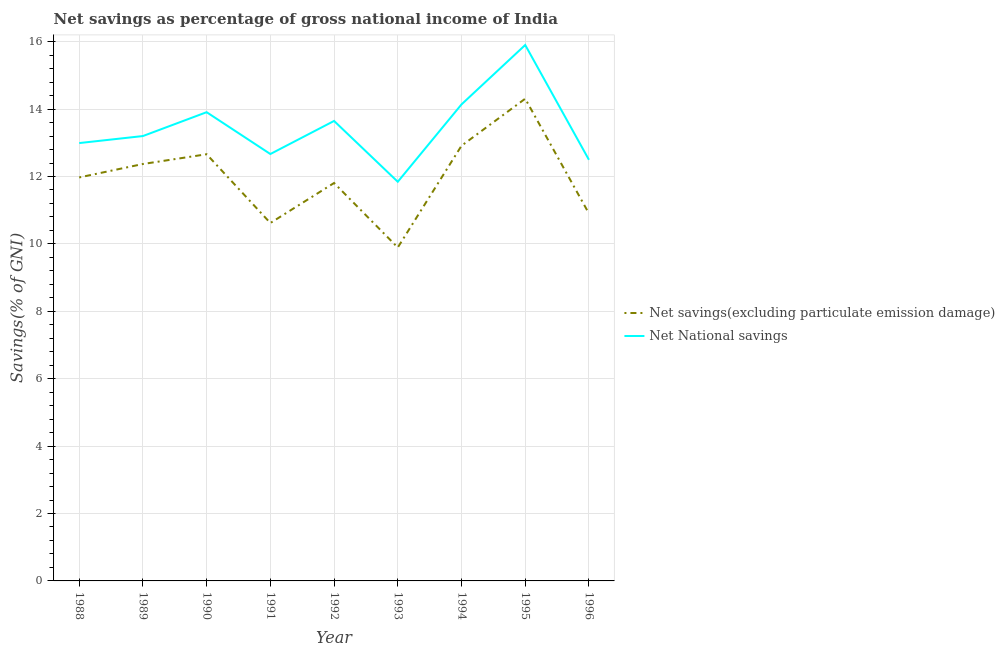How many different coloured lines are there?
Give a very brief answer. 2. Does the line corresponding to net national savings intersect with the line corresponding to net savings(excluding particulate emission damage)?
Your answer should be compact. No. Is the number of lines equal to the number of legend labels?
Make the answer very short. Yes. What is the net savings(excluding particulate emission damage) in 1994?
Your response must be concise. 12.91. Across all years, what is the maximum net savings(excluding particulate emission damage)?
Your answer should be compact. 14.31. Across all years, what is the minimum net savings(excluding particulate emission damage)?
Offer a terse response. 9.89. In which year was the net savings(excluding particulate emission damage) minimum?
Your answer should be compact. 1993. What is the total net national savings in the graph?
Offer a very short reply. 120.79. What is the difference between the net savings(excluding particulate emission damage) in 1993 and that in 1996?
Your answer should be very brief. -1.01. What is the difference between the net national savings in 1995 and the net savings(excluding particulate emission damage) in 1992?
Offer a terse response. 4.09. What is the average net savings(excluding particulate emission damage) per year?
Provide a short and direct response. 11.94. In the year 1989, what is the difference between the net national savings and net savings(excluding particulate emission damage)?
Your answer should be very brief. 0.83. In how many years, is the net savings(excluding particulate emission damage) greater than 14 %?
Offer a very short reply. 1. What is the ratio of the net national savings in 1990 to that in 1996?
Offer a terse response. 1.11. What is the difference between the highest and the second highest net national savings?
Make the answer very short. 1.76. What is the difference between the highest and the lowest net national savings?
Give a very brief answer. 4.06. Is the sum of the net national savings in 1990 and 1991 greater than the maximum net savings(excluding particulate emission damage) across all years?
Offer a very short reply. Yes. Does the net savings(excluding particulate emission damage) monotonically increase over the years?
Ensure brevity in your answer.  No. Is the net savings(excluding particulate emission damage) strictly less than the net national savings over the years?
Make the answer very short. Yes. How many years are there in the graph?
Give a very brief answer. 9. What is the difference between two consecutive major ticks on the Y-axis?
Provide a short and direct response. 2. Are the values on the major ticks of Y-axis written in scientific E-notation?
Make the answer very short. No. Does the graph contain any zero values?
Keep it short and to the point. No. How are the legend labels stacked?
Keep it short and to the point. Vertical. What is the title of the graph?
Your answer should be compact. Net savings as percentage of gross national income of India. Does "Broad money growth" appear as one of the legend labels in the graph?
Keep it short and to the point. No. What is the label or title of the Y-axis?
Make the answer very short. Savings(% of GNI). What is the Savings(% of GNI) of Net savings(excluding particulate emission damage) in 1988?
Provide a succinct answer. 11.97. What is the Savings(% of GNI) of Net National savings in 1988?
Offer a terse response. 12.99. What is the Savings(% of GNI) of Net savings(excluding particulate emission damage) in 1989?
Provide a succinct answer. 12.37. What is the Savings(% of GNI) of Net National savings in 1989?
Provide a succinct answer. 13.2. What is the Savings(% of GNI) in Net savings(excluding particulate emission damage) in 1990?
Give a very brief answer. 12.66. What is the Savings(% of GNI) of Net National savings in 1990?
Your answer should be very brief. 13.91. What is the Savings(% of GNI) of Net savings(excluding particulate emission damage) in 1991?
Offer a terse response. 10.62. What is the Savings(% of GNI) in Net National savings in 1991?
Your answer should be very brief. 12.67. What is the Savings(% of GNI) in Net savings(excluding particulate emission damage) in 1992?
Provide a short and direct response. 11.81. What is the Savings(% of GNI) in Net National savings in 1992?
Make the answer very short. 13.65. What is the Savings(% of GNI) of Net savings(excluding particulate emission damage) in 1993?
Your answer should be very brief. 9.89. What is the Savings(% of GNI) of Net National savings in 1993?
Your response must be concise. 11.84. What is the Savings(% of GNI) of Net savings(excluding particulate emission damage) in 1994?
Your answer should be compact. 12.91. What is the Savings(% of GNI) of Net National savings in 1994?
Provide a succinct answer. 14.14. What is the Savings(% of GNI) of Net savings(excluding particulate emission damage) in 1995?
Offer a terse response. 14.31. What is the Savings(% of GNI) of Net National savings in 1995?
Provide a succinct answer. 15.9. What is the Savings(% of GNI) in Net savings(excluding particulate emission damage) in 1996?
Ensure brevity in your answer.  10.9. What is the Savings(% of GNI) in Net National savings in 1996?
Offer a very short reply. 12.5. Across all years, what is the maximum Savings(% of GNI) in Net savings(excluding particulate emission damage)?
Give a very brief answer. 14.31. Across all years, what is the maximum Savings(% of GNI) of Net National savings?
Provide a short and direct response. 15.9. Across all years, what is the minimum Savings(% of GNI) of Net savings(excluding particulate emission damage)?
Provide a succinct answer. 9.89. Across all years, what is the minimum Savings(% of GNI) in Net National savings?
Your response must be concise. 11.84. What is the total Savings(% of GNI) of Net savings(excluding particulate emission damage) in the graph?
Your response must be concise. 107.44. What is the total Savings(% of GNI) in Net National savings in the graph?
Ensure brevity in your answer.  120.79. What is the difference between the Savings(% of GNI) in Net savings(excluding particulate emission damage) in 1988 and that in 1989?
Keep it short and to the point. -0.4. What is the difference between the Savings(% of GNI) of Net National savings in 1988 and that in 1989?
Provide a short and direct response. -0.21. What is the difference between the Savings(% of GNI) in Net savings(excluding particulate emission damage) in 1988 and that in 1990?
Provide a succinct answer. -0.69. What is the difference between the Savings(% of GNI) in Net National savings in 1988 and that in 1990?
Offer a very short reply. -0.92. What is the difference between the Savings(% of GNI) of Net savings(excluding particulate emission damage) in 1988 and that in 1991?
Ensure brevity in your answer.  1.35. What is the difference between the Savings(% of GNI) in Net National savings in 1988 and that in 1991?
Ensure brevity in your answer.  0.32. What is the difference between the Savings(% of GNI) in Net savings(excluding particulate emission damage) in 1988 and that in 1992?
Provide a short and direct response. 0.17. What is the difference between the Savings(% of GNI) in Net National savings in 1988 and that in 1992?
Your response must be concise. -0.66. What is the difference between the Savings(% of GNI) in Net savings(excluding particulate emission damage) in 1988 and that in 1993?
Your response must be concise. 2.08. What is the difference between the Savings(% of GNI) in Net National savings in 1988 and that in 1993?
Your answer should be very brief. 1.15. What is the difference between the Savings(% of GNI) in Net savings(excluding particulate emission damage) in 1988 and that in 1994?
Provide a succinct answer. -0.94. What is the difference between the Savings(% of GNI) in Net National savings in 1988 and that in 1994?
Offer a terse response. -1.15. What is the difference between the Savings(% of GNI) in Net savings(excluding particulate emission damage) in 1988 and that in 1995?
Offer a very short reply. -2.34. What is the difference between the Savings(% of GNI) of Net National savings in 1988 and that in 1995?
Your answer should be compact. -2.91. What is the difference between the Savings(% of GNI) in Net savings(excluding particulate emission damage) in 1988 and that in 1996?
Offer a very short reply. 1.07. What is the difference between the Savings(% of GNI) in Net National savings in 1988 and that in 1996?
Offer a very short reply. 0.5. What is the difference between the Savings(% of GNI) of Net savings(excluding particulate emission damage) in 1989 and that in 1990?
Ensure brevity in your answer.  -0.29. What is the difference between the Savings(% of GNI) of Net National savings in 1989 and that in 1990?
Offer a terse response. -0.71. What is the difference between the Savings(% of GNI) of Net savings(excluding particulate emission damage) in 1989 and that in 1991?
Your answer should be compact. 1.75. What is the difference between the Savings(% of GNI) in Net National savings in 1989 and that in 1991?
Your answer should be very brief. 0.53. What is the difference between the Savings(% of GNI) of Net savings(excluding particulate emission damage) in 1989 and that in 1992?
Offer a very short reply. 0.56. What is the difference between the Savings(% of GNI) in Net National savings in 1989 and that in 1992?
Offer a terse response. -0.45. What is the difference between the Savings(% of GNI) of Net savings(excluding particulate emission damage) in 1989 and that in 1993?
Your answer should be compact. 2.48. What is the difference between the Savings(% of GNI) in Net National savings in 1989 and that in 1993?
Your answer should be very brief. 1.36. What is the difference between the Savings(% of GNI) of Net savings(excluding particulate emission damage) in 1989 and that in 1994?
Ensure brevity in your answer.  -0.54. What is the difference between the Savings(% of GNI) in Net National savings in 1989 and that in 1994?
Make the answer very short. -0.94. What is the difference between the Savings(% of GNI) of Net savings(excluding particulate emission damage) in 1989 and that in 1995?
Your response must be concise. -1.94. What is the difference between the Savings(% of GNI) of Net National savings in 1989 and that in 1995?
Ensure brevity in your answer.  -2.7. What is the difference between the Savings(% of GNI) in Net savings(excluding particulate emission damage) in 1989 and that in 1996?
Your answer should be compact. 1.47. What is the difference between the Savings(% of GNI) in Net National savings in 1989 and that in 1996?
Provide a short and direct response. 0.7. What is the difference between the Savings(% of GNI) of Net savings(excluding particulate emission damage) in 1990 and that in 1991?
Ensure brevity in your answer.  2.04. What is the difference between the Savings(% of GNI) of Net National savings in 1990 and that in 1991?
Offer a terse response. 1.24. What is the difference between the Savings(% of GNI) of Net savings(excluding particulate emission damage) in 1990 and that in 1992?
Keep it short and to the point. 0.85. What is the difference between the Savings(% of GNI) in Net National savings in 1990 and that in 1992?
Your answer should be compact. 0.26. What is the difference between the Savings(% of GNI) in Net savings(excluding particulate emission damage) in 1990 and that in 1993?
Your answer should be very brief. 2.77. What is the difference between the Savings(% of GNI) in Net National savings in 1990 and that in 1993?
Make the answer very short. 2.06. What is the difference between the Savings(% of GNI) in Net savings(excluding particulate emission damage) in 1990 and that in 1994?
Give a very brief answer. -0.25. What is the difference between the Savings(% of GNI) in Net National savings in 1990 and that in 1994?
Ensure brevity in your answer.  -0.23. What is the difference between the Savings(% of GNI) in Net savings(excluding particulate emission damage) in 1990 and that in 1995?
Your answer should be compact. -1.65. What is the difference between the Savings(% of GNI) in Net National savings in 1990 and that in 1995?
Your response must be concise. -1.99. What is the difference between the Savings(% of GNI) in Net savings(excluding particulate emission damage) in 1990 and that in 1996?
Give a very brief answer. 1.76. What is the difference between the Savings(% of GNI) of Net National savings in 1990 and that in 1996?
Your answer should be very brief. 1.41. What is the difference between the Savings(% of GNI) of Net savings(excluding particulate emission damage) in 1991 and that in 1992?
Provide a short and direct response. -1.19. What is the difference between the Savings(% of GNI) of Net National savings in 1991 and that in 1992?
Give a very brief answer. -0.98. What is the difference between the Savings(% of GNI) in Net savings(excluding particulate emission damage) in 1991 and that in 1993?
Ensure brevity in your answer.  0.73. What is the difference between the Savings(% of GNI) of Net National savings in 1991 and that in 1993?
Make the answer very short. 0.82. What is the difference between the Savings(% of GNI) in Net savings(excluding particulate emission damage) in 1991 and that in 1994?
Your answer should be very brief. -2.29. What is the difference between the Savings(% of GNI) in Net National savings in 1991 and that in 1994?
Provide a short and direct response. -1.47. What is the difference between the Savings(% of GNI) of Net savings(excluding particulate emission damage) in 1991 and that in 1995?
Your answer should be very brief. -3.69. What is the difference between the Savings(% of GNI) in Net National savings in 1991 and that in 1995?
Your answer should be very brief. -3.23. What is the difference between the Savings(% of GNI) of Net savings(excluding particulate emission damage) in 1991 and that in 1996?
Your response must be concise. -0.28. What is the difference between the Savings(% of GNI) of Net National savings in 1991 and that in 1996?
Your response must be concise. 0.17. What is the difference between the Savings(% of GNI) of Net savings(excluding particulate emission damage) in 1992 and that in 1993?
Your response must be concise. 1.91. What is the difference between the Savings(% of GNI) of Net National savings in 1992 and that in 1993?
Offer a very short reply. 1.8. What is the difference between the Savings(% of GNI) of Net savings(excluding particulate emission damage) in 1992 and that in 1994?
Offer a terse response. -1.1. What is the difference between the Savings(% of GNI) in Net National savings in 1992 and that in 1994?
Keep it short and to the point. -0.49. What is the difference between the Savings(% of GNI) in Net savings(excluding particulate emission damage) in 1992 and that in 1995?
Your answer should be compact. -2.5. What is the difference between the Savings(% of GNI) in Net National savings in 1992 and that in 1995?
Your answer should be compact. -2.25. What is the difference between the Savings(% of GNI) in Net savings(excluding particulate emission damage) in 1992 and that in 1996?
Give a very brief answer. 0.91. What is the difference between the Savings(% of GNI) of Net National savings in 1992 and that in 1996?
Your response must be concise. 1.15. What is the difference between the Savings(% of GNI) in Net savings(excluding particulate emission damage) in 1993 and that in 1994?
Provide a succinct answer. -3.02. What is the difference between the Savings(% of GNI) of Net National savings in 1993 and that in 1994?
Provide a short and direct response. -2.3. What is the difference between the Savings(% of GNI) of Net savings(excluding particulate emission damage) in 1993 and that in 1995?
Give a very brief answer. -4.42. What is the difference between the Savings(% of GNI) of Net National savings in 1993 and that in 1995?
Give a very brief answer. -4.06. What is the difference between the Savings(% of GNI) of Net savings(excluding particulate emission damage) in 1993 and that in 1996?
Provide a succinct answer. -1.01. What is the difference between the Savings(% of GNI) in Net National savings in 1993 and that in 1996?
Provide a short and direct response. -0.65. What is the difference between the Savings(% of GNI) in Net savings(excluding particulate emission damage) in 1994 and that in 1995?
Give a very brief answer. -1.4. What is the difference between the Savings(% of GNI) of Net National savings in 1994 and that in 1995?
Your answer should be compact. -1.76. What is the difference between the Savings(% of GNI) of Net savings(excluding particulate emission damage) in 1994 and that in 1996?
Your answer should be compact. 2.01. What is the difference between the Savings(% of GNI) of Net National savings in 1994 and that in 1996?
Offer a very short reply. 1.64. What is the difference between the Savings(% of GNI) in Net savings(excluding particulate emission damage) in 1995 and that in 1996?
Your response must be concise. 3.41. What is the difference between the Savings(% of GNI) in Net National savings in 1995 and that in 1996?
Offer a very short reply. 3.41. What is the difference between the Savings(% of GNI) in Net savings(excluding particulate emission damage) in 1988 and the Savings(% of GNI) in Net National savings in 1989?
Ensure brevity in your answer.  -1.23. What is the difference between the Savings(% of GNI) of Net savings(excluding particulate emission damage) in 1988 and the Savings(% of GNI) of Net National savings in 1990?
Provide a short and direct response. -1.94. What is the difference between the Savings(% of GNI) of Net savings(excluding particulate emission damage) in 1988 and the Savings(% of GNI) of Net National savings in 1991?
Your response must be concise. -0.69. What is the difference between the Savings(% of GNI) in Net savings(excluding particulate emission damage) in 1988 and the Savings(% of GNI) in Net National savings in 1992?
Make the answer very short. -1.68. What is the difference between the Savings(% of GNI) in Net savings(excluding particulate emission damage) in 1988 and the Savings(% of GNI) in Net National savings in 1993?
Your answer should be compact. 0.13. What is the difference between the Savings(% of GNI) in Net savings(excluding particulate emission damage) in 1988 and the Savings(% of GNI) in Net National savings in 1994?
Ensure brevity in your answer.  -2.17. What is the difference between the Savings(% of GNI) of Net savings(excluding particulate emission damage) in 1988 and the Savings(% of GNI) of Net National savings in 1995?
Provide a succinct answer. -3.93. What is the difference between the Savings(% of GNI) in Net savings(excluding particulate emission damage) in 1988 and the Savings(% of GNI) in Net National savings in 1996?
Your answer should be very brief. -0.52. What is the difference between the Savings(% of GNI) of Net savings(excluding particulate emission damage) in 1989 and the Savings(% of GNI) of Net National savings in 1990?
Offer a terse response. -1.54. What is the difference between the Savings(% of GNI) in Net savings(excluding particulate emission damage) in 1989 and the Savings(% of GNI) in Net National savings in 1991?
Your answer should be compact. -0.3. What is the difference between the Savings(% of GNI) in Net savings(excluding particulate emission damage) in 1989 and the Savings(% of GNI) in Net National savings in 1992?
Offer a terse response. -1.28. What is the difference between the Savings(% of GNI) in Net savings(excluding particulate emission damage) in 1989 and the Savings(% of GNI) in Net National savings in 1993?
Ensure brevity in your answer.  0.53. What is the difference between the Savings(% of GNI) in Net savings(excluding particulate emission damage) in 1989 and the Savings(% of GNI) in Net National savings in 1994?
Provide a short and direct response. -1.77. What is the difference between the Savings(% of GNI) in Net savings(excluding particulate emission damage) in 1989 and the Savings(% of GNI) in Net National savings in 1995?
Your answer should be compact. -3.53. What is the difference between the Savings(% of GNI) in Net savings(excluding particulate emission damage) in 1989 and the Savings(% of GNI) in Net National savings in 1996?
Provide a succinct answer. -0.12. What is the difference between the Savings(% of GNI) in Net savings(excluding particulate emission damage) in 1990 and the Savings(% of GNI) in Net National savings in 1991?
Provide a succinct answer. -0.01. What is the difference between the Savings(% of GNI) of Net savings(excluding particulate emission damage) in 1990 and the Savings(% of GNI) of Net National savings in 1992?
Offer a very short reply. -0.99. What is the difference between the Savings(% of GNI) of Net savings(excluding particulate emission damage) in 1990 and the Savings(% of GNI) of Net National savings in 1993?
Offer a terse response. 0.82. What is the difference between the Savings(% of GNI) in Net savings(excluding particulate emission damage) in 1990 and the Savings(% of GNI) in Net National savings in 1994?
Provide a succinct answer. -1.48. What is the difference between the Savings(% of GNI) in Net savings(excluding particulate emission damage) in 1990 and the Savings(% of GNI) in Net National savings in 1995?
Make the answer very short. -3.24. What is the difference between the Savings(% of GNI) of Net savings(excluding particulate emission damage) in 1990 and the Savings(% of GNI) of Net National savings in 1996?
Your answer should be compact. 0.16. What is the difference between the Savings(% of GNI) of Net savings(excluding particulate emission damage) in 1991 and the Savings(% of GNI) of Net National savings in 1992?
Make the answer very short. -3.03. What is the difference between the Savings(% of GNI) in Net savings(excluding particulate emission damage) in 1991 and the Savings(% of GNI) in Net National savings in 1993?
Make the answer very short. -1.22. What is the difference between the Savings(% of GNI) in Net savings(excluding particulate emission damage) in 1991 and the Savings(% of GNI) in Net National savings in 1994?
Make the answer very short. -3.52. What is the difference between the Savings(% of GNI) in Net savings(excluding particulate emission damage) in 1991 and the Savings(% of GNI) in Net National savings in 1995?
Keep it short and to the point. -5.28. What is the difference between the Savings(% of GNI) of Net savings(excluding particulate emission damage) in 1991 and the Savings(% of GNI) of Net National savings in 1996?
Give a very brief answer. -1.88. What is the difference between the Savings(% of GNI) in Net savings(excluding particulate emission damage) in 1992 and the Savings(% of GNI) in Net National savings in 1993?
Keep it short and to the point. -0.04. What is the difference between the Savings(% of GNI) in Net savings(excluding particulate emission damage) in 1992 and the Savings(% of GNI) in Net National savings in 1994?
Your answer should be compact. -2.33. What is the difference between the Savings(% of GNI) of Net savings(excluding particulate emission damage) in 1992 and the Savings(% of GNI) of Net National savings in 1995?
Offer a very short reply. -4.09. What is the difference between the Savings(% of GNI) of Net savings(excluding particulate emission damage) in 1992 and the Savings(% of GNI) of Net National savings in 1996?
Your answer should be very brief. -0.69. What is the difference between the Savings(% of GNI) in Net savings(excluding particulate emission damage) in 1993 and the Savings(% of GNI) in Net National savings in 1994?
Provide a short and direct response. -4.25. What is the difference between the Savings(% of GNI) in Net savings(excluding particulate emission damage) in 1993 and the Savings(% of GNI) in Net National savings in 1995?
Provide a short and direct response. -6.01. What is the difference between the Savings(% of GNI) in Net savings(excluding particulate emission damage) in 1993 and the Savings(% of GNI) in Net National savings in 1996?
Your answer should be very brief. -2.6. What is the difference between the Savings(% of GNI) in Net savings(excluding particulate emission damage) in 1994 and the Savings(% of GNI) in Net National savings in 1995?
Offer a very short reply. -2.99. What is the difference between the Savings(% of GNI) of Net savings(excluding particulate emission damage) in 1994 and the Savings(% of GNI) of Net National savings in 1996?
Your answer should be compact. 0.42. What is the difference between the Savings(% of GNI) in Net savings(excluding particulate emission damage) in 1995 and the Savings(% of GNI) in Net National savings in 1996?
Your answer should be compact. 1.81. What is the average Savings(% of GNI) of Net savings(excluding particulate emission damage) per year?
Provide a short and direct response. 11.94. What is the average Savings(% of GNI) of Net National savings per year?
Your answer should be compact. 13.42. In the year 1988, what is the difference between the Savings(% of GNI) in Net savings(excluding particulate emission damage) and Savings(% of GNI) in Net National savings?
Give a very brief answer. -1.02. In the year 1989, what is the difference between the Savings(% of GNI) of Net savings(excluding particulate emission damage) and Savings(% of GNI) of Net National savings?
Keep it short and to the point. -0.83. In the year 1990, what is the difference between the Savings(% of GNI) in Net savings(excluding particulate emission damage) and Savings(% of GNI) in Net National savings?
Offer a terse response. -1.25. In the year 1991, what is the difference between the Savings(% of GNI) in Net savings(excluding particulate emission damage) and Savings(% of GNI) in Net National savings?
Make the answer very short. -2.05. In the year 1992, what is the difference between the Savings(% of GNI) in Net savings(excluding particulate emission damage) and Savings(% of GNI) in Net National savings?
Keep it short and to the point. -1.84. In the year 1993, what is the difference between the Savings(% of GNI) in Net savings(excluding particulate emission damage) and Savings(% of GNI) in Net National savings?
Provide a short and direct response. -1.95. In the year 1994, what is the difference between the Savings(% of GNI) in Net savings(excluding particulate emission damage) and Savings(% of GNI) in Net National savings?
Your answer should be compact. -1.23. In the year 1995, what is the difference between the Savings(% of GNI) of Net savings(excluding particulate emission damage) and Savings(% of GNI) of Net National savings?
Give a very brief answer. -1.59. In the year 1996, what is the difference between the Savings(% of GNI) in Net savings(excluding particulate emission damage) and Savings(% of GNI) in Net National savings?
Your response must be concise. -1.59. What is the ratio of the Savings(% of GNI) of Net savings(excluding particulate emission damage) in 1988 to that in 1989?
Provide a short and direct response. 0.97. What is the ratio of the Savings(% of GNI) in Net National savings in 1988 to that in 1989?
Keep it short and to the point. 0.98. What is the ratio of the Savings(% of GNI) in Net savings(excluding particulate emission damage) in 1988 to that in 1990?
Make the answer very short. 0.95. What is the ratio of the Savings(% of GNI) in Net National savings in 1988 to that in 1990?
Keep it short and to the point. 0.93. What is the ratio of the Savings(% of GNI) of Net savings(excluding particulate emission damage) in 1988 to that in 1991?
Your answer should be compact. 1.13. What is the ratio of the Savings(% of GNI) in Net National savings in 1988 to that in 1991?
Your answer should be compact. 1.03. What is the ratio of the Savings(% of GNI) of Net savings(excluding particulate emission damage) in 1988 to that in 1992?
Provide a short and direct response. 1.01. What is the ratio of the Savings(% of GNI) in Net National savings in 1988 to that in 1992?
Provide a succinct answer. 0.95. What is the ratio of the Savings(% of GNI) of Net savings(excluding particulate emission damage) in 1988 to that in 1993?
Your answer should be very brief. 1.21. What is the ratio of the Savings(% of GNI) in Net National savings in 1988 to that in 1993?
Your response must be concise. 1.1. What is the ratio of the Savings(% of GNI) of Net savings(excluding particulate emission damage) in 1988 to that in 1994?
Keep it short and to the point. 0.93. What is the ratio of the Savings(% of GNI) in Net National savings in 1988 to that in 1994?
Ensure brevity in your answer.  0.92. What is the ratio of the Savings(% of GNI) in Net savings(excluding particulate emission damage) in 1988 to that in 1995?
Offer a terse response. 0.84. What is the ratio of the Savings(% of GNI) of Net National savings in 1988 to that in 1995?
Offer a very short reply. 0.82. What is the ratio of the Savings(% of GNI) of Net savings(excluding particulate emission damage) in 1988 to that in 1996?
Give a very brief answer. 1.1. What is the ratio of the Savings(% of GNI) of Net National savings in 1988 to that in 1996?
Offer a very short reply. 1.04. What is the ratio of the Savings(% of GNI) of Net savings(excluding particulate emission damage) in 1989 to that in 1990?
Offer a terse response. 0.98. What is the ratio of the Savings(% of GNI) in Net National savings in 1989 to that in 1990?
Make the answer very short. 0.95. What is the ratio of the Savings(% of GNI) in Net savings(excluding particulate emission damage) in 1989 to that in 1991?
Offer a very short reply. 1.16. What is the ratio of the Savings(% of GNI) of Net National savings in 1989 to that in 1991?
Make the answer very short. 1.04. What is the ratio of the Savings(% of GNI) of Net savings(excluding particulate emission damage) in 1989 to that in 1992?
Your answer should be very brief. 1.05. What is the ratio of the Savings(% of GNI) in Net National savings in 1989 to that in 1992?
Make the answer very short. 0.97. What is the ratio of the Savings(% of GNI) of Net savings(excluding particulate emission damage) in 1989 to that in 1993?
Provide a succinct answer. 1.25. What is the ratio of the Savings(% of GNI) of Net National savings in 1989 to that in 1993?
Your answer should be compact. 1.11. What is the ratio of the Savings(% of GNI) of Net savings(excluding particulate emission damage) in 1989 to that in 1994?
Give a very brief answer. 0.96. What is the ratio of the Savings(% of GNI) of Net National savings in 1989 to that in 1994?
Your answer should be compact. 0.93. What is the ratio of the Savings(% of GNI) in Net savings(excluding particulate emission damage) in 1989 to that in 1995?
Provide a succinct answer. 0.86. What is the ratio of the Savings(% of GNI) in Net National savings in 1989 to that in 1995?
Give a very brief answer. 0.83. What is the ratio of the Savings(% of GNI) in Net savings(excluding particulate emission damage) in 1989 to that in 1996?
Your response must be concise. 1.13. What is the ratio of the Savings(% of GNI) in Net National savings in 1989 to that in 1996?
Provide a short and direct response. 1.06. What is the ratio of the Savings(% of GNI) of Net savings(excluding particulate emission damage) in 1990 to that in 1991?
Offer a very short reply. 1.19. What is the ratio of the Savings(% of GNI) in Net National savings in 1990 to that in 1991?
Keep it short and to the point. 1.1. What is the ratio of the Savings(% of GNI) in Net savings(excluding particulate emission damage) in 1990 to that in 1992?
Provide a succinct answer. 1.07. What is the ratio of the Savings(% of GNI) of Net savings(excluding particulate emission damage) in 1990 to that in 1993?
Offer a very short reply. 1.28. What is the ratio of the Savings(% of GNI) in Net National savings in 1990 to that in 1993?
Provide a short and direct response. 1.17. What is the ratio of the Savings(% of GNI) in Net savings(excluding particulate emission damage) in 1990 to that in 1994?
Your answer should be very brief. 0.98. What is the ratio of the Savings(% of GNI) in Net National savings in 1990 to that in 1994?
Offer a very short reply. 0.98. What is the ratio of the Savings(% of GNI) in Net savings(excluding particulate emission damage) in 1990 to that in 1995?
Ensure brevity in your answer.  0.88. What is the ratio of the Savings(% of GNI) in Net National savings in 1990 to that in 1995?
Keep it short and to the point. 0.87. What is the ratio of the Savings(% of GNI) of Net savings(excluding particulate emission damage) in 1990 to that in 1996?
Keep it short and to the point. 1.16. What is the ratio of the Savings(% of GNI) of Net National savings in 1990 to that in 1996?
Offer a terse response. 1.11. What is the ratio of the Savings(% of GNI) of Net savings(excluding particulate emission damage) in 1991 to that in 1992?
Provide a succinct answer. 0.9. What is the ratio of the Savings(% of GNI) of Net National savings in 1991 to that in 1992?
Your response must be concise. 0.93. What is the ratio of the Savings(% of GNI) of Net savings(excluding particulate emission damage) in 1991 to that in 1993?
Your answer should be compact. 1.07. What is the ratio of the Savings(% of GNI) of Net National savings in 1991 to that in 1993?
Your response must be concise. 1.07. What is the ratio of the Savings(% of GNI) in Net savings(excluding particulate emission damage) in 1991 to that in 1994?
Provide a short and direct response. 0.82. What is the ratio of the Savings(% of GNI) of Net National savings in 1991 to that in 1994?
Your response must be concise. 0.9. What is the ratio of the Savings(% of GNI) of Net savings(excluding particulate emission damage) in 1991 to that in 1995?
Your response must be concise. 0.74. What is the ratio of the Savings(% of GNI) of Net National savings in 1991 to that in 1995?
Offer a terse response. 0.8. What is the ratio of the Savings(% of GNI) in Net savings(excluding particulate emission damage) in 1991 to that in 1996?
Your response must be concise. 0.97. What is the ratio of the Savings(% of GNI) of Net National savings in 1991 to that in 1996?
Ensure brevity in your answer.  1.01. What is the ratio of the Savings(% of GNI) in Net savings(excluding particulate emission damage) in 1992 to that in 1993?
Provide a succinct answer. 1.19. What is the ratio of the Savings(% of GNI) of Net National savings in 1992 to that in 1993?
Your answer should be compact. 1.15. What is the ratio of the Savings(% of GNI) in Net savings(excluding particulate emission damage) in 1992 to that in 1994?
Offer a very short reply. 0.91. What is the ratio of the Savings(% of GNI) of Net National savings in 1992 to that in 1994?
Ensure brevity in your answer.  0.97. What is the ratio of the Savings(% of GNI) of Net savings(excluding particulate emission damage) in 1992 to that in 1995?
Keep it short and to the point. 0.83. What is the ratio of the Savings(% of GNI) in Net National savings in 1992 to that in 1995?
Provide a short and direct response. 0.86. What is the ratio of the Savings(% of GNI) in Net savings(excluding particulate emission damage) in 1992 to that in 1996?
Offer a terse response. 1.08. What is the ratio of the Savings(% of GNI) of Net National savings in 1992 to that in 1996?
Your answer should be compact. 1.09. What is the ratio of the Savings(% of GNI) of Net savings(excluding particulate emission damage) in 1993 to that in 1994?
Your response must be concise. 0.77. What is the ratio of the Savings(% of GNI) in Net National savings in 1993 to that in 1994?
Make the answer very short. 0.84. What is the ratio of the Savings(% of GNI) of Net savings(excluding particulate emission damage) in 1993 to that in 1995?
Provide a short and direct response. 0.69. What is the ratio of the Savings(% of GNI) of Net National savings in 1993 to that in 1995?
Make the answer very short. 0.74. What is the ratio of the Savings(% of GNI) of Net savings(excluding particulate emission damage) in 1993 to that in 1996?
Your answer should be compact. 0.91. What is the ratio of the Savings(% of GNI) in Net National savings in 1993 to that in 1996?
Give a very brief answer. 0.95. What is the ratio of the Savings(% of GNI) in Net savings(excluding particulate emission damage) in 1994 to that in 1995?
Make the answer very short. 0.9. What is the ratio of the Savings(% of GNI) in Net National savings in 1994 to that in 1995?
Give a very brief answer. 0.89. What is the ratio of the Savings(% of GNI) in Net savings(excluding particulate emission damage) in 1994 to that in 1996?
Keep it short and to the point. 1.18. What is the ratio of the Savings(% of GNI) in Net National savings in 1994 to that in 1996?
Offer a very short reply. 1.13. What is the ratio of the Savings(% of GNI) in Net savings(excluding particulate emission damage) in 1995 to that in 1996?
Keep it short and to the point. 1.31. What is the ratio of the Savings(% of GNI) of Net National savings in 1995 to that in 1996?
Provide a succinct answer. 1.27. What is the difference between the highest and the second highest Savings(% of GNI) in Net savings(excluding particulate emission damage)?
Your answer should be compact. 1.4. What is the difference between the highest and the second highest Savings(% of GNI) of Net National savings?
Give a very brief answer. 1.76. What is the difference between the highest and the lowest Savings(% of GNI) in Net savings(excluding particulate emission damage)?
Give a very brief answer. 4.42. What is the difference between the highest and the lowest Savings(% of GNI) in Net National savings?
Provide a succinct answer. 4.06. 